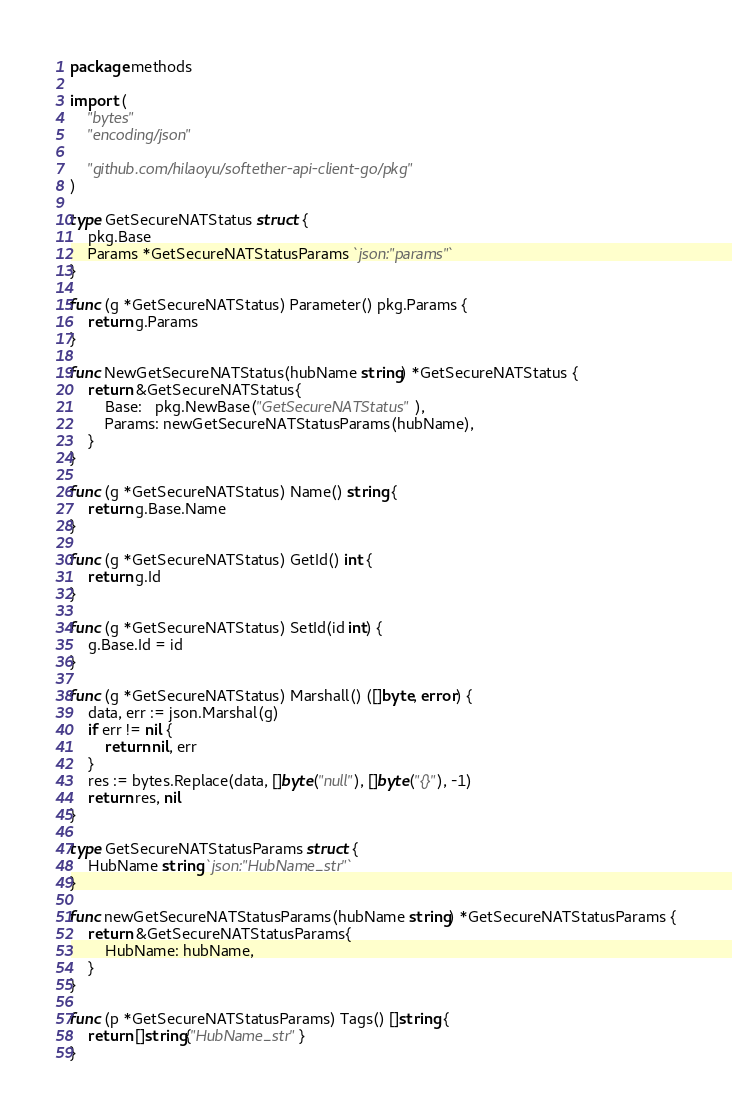Convert code to text. <code><loc_0><loc_0><loc_500><loc_500><_Go_>package methods

import (
	"bytes"
	"encoding/json"

	"github.com/hilaoyu/softether-api-client-go/pkg"
)

type GetSecureNATStatus struct {
	pkg.Base
	Params *GetSecureNATStatusParams `json:"params"`
}

func (g *GetSecureNATStatus) Parameter() pkg.Params {
	return g.Params
}

func NewGetSecureNATStatus(hubName string) *GetSecureNATStatus {
	return &GetSecureNATStatus{
		Base:   pkg.NewBase("GetSecureNATStatus"),
		Params: newGetSecureNATStatusParams(hubName),
	}
}

func (g *GetSecureNATStatus) Name() string {
	return g.Base.Name
}

func (g *GetSecureNATStatus) GetId() int {
	return g.Id
}

func (g *GetSecureNATStatus) SetId(id int) {
	g.Base.Id = id
}

func (g *GetSecureNATStatus) Marshall() ([]byte, error) {
	data, err := json.Marshal(g)
	if err != nil {
		return nil, err
	}
	res := bytes.Replace(data, []byte("null"), []byte("{}"), -1)
	return res, nil
}

type GetSecureNATStatusParams struct {
	HubName string `json:"HubName_str"`
}

func newGetSecureNATStatusParams(hubName string) *GetSecureNATStatusParams {
	return &GetSecureNATStatusParams{
		HubName: hubName,
	}
}

func (p *GetSecureNATStatusParams) Tags() []string {
	return []string{"HubName_str"}
}
</code> 